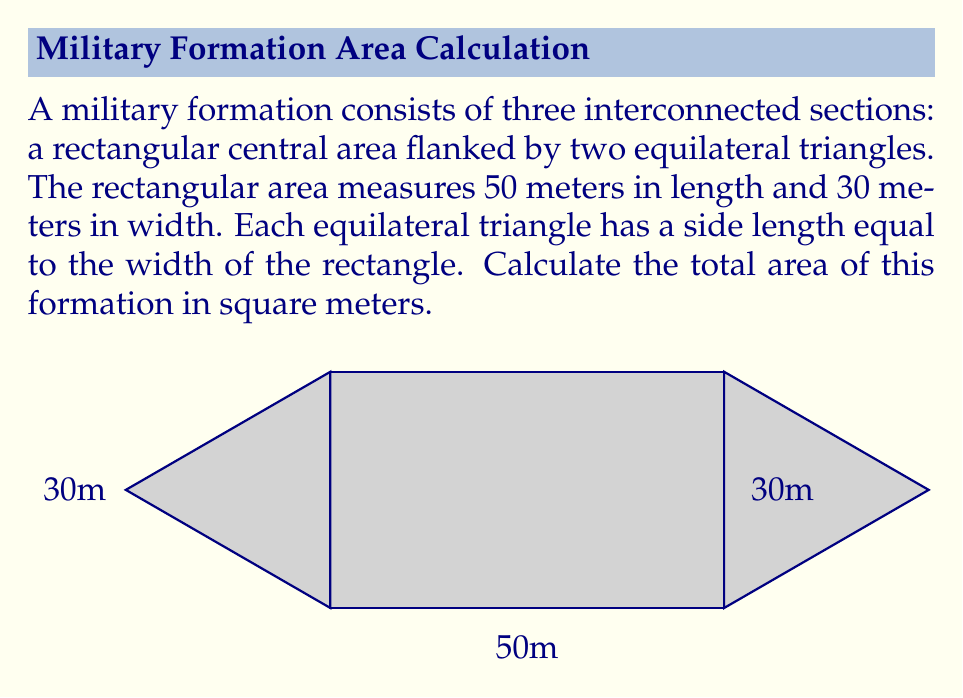What is the answer to this math problem? Let's break this down step-by-step:

1) First, calculate the area of the rectangular central section:
   $A_{rectangle} = length \times width = 50m \times 30m = 1500m^2$

2) Now, for each equilateral triangle:
   - The side length is equal to the width of the rectangle, so $s = 30m$
   - The area of an equilateral triangle is given by the formula:
     $$A_{triangle} = \frac{\sqrt{3}}{4}s^2$$

3) Substituting $s = 30m$ into this formula:
   $$A_{triangle} = \frac{\sqrt{3}}{4}(30m)^2 = \frac{\sqrt{3}}{4} \times 900m^2 = 225\sqrt{3}m^2$$

4) There are two such triangles, so the total area of the triangles is:
   $2 \times 225\sqrt{3}m^2 = 450\sqrt{3}m^2$

5) The total area of the formation is the sum of the rectangular area and the two triangular areas:
   $$A_{total} = A_{rectangle} + 2A_{triangle} = 1500m^2 + 450\sqrt{3}m^2$$

6) This can be simplified to:
   $$A_{total} = (1500 + 450\sqrt{3})m^2$$
Answer: $(1500 + 450\sqrt{3})m^2$ 